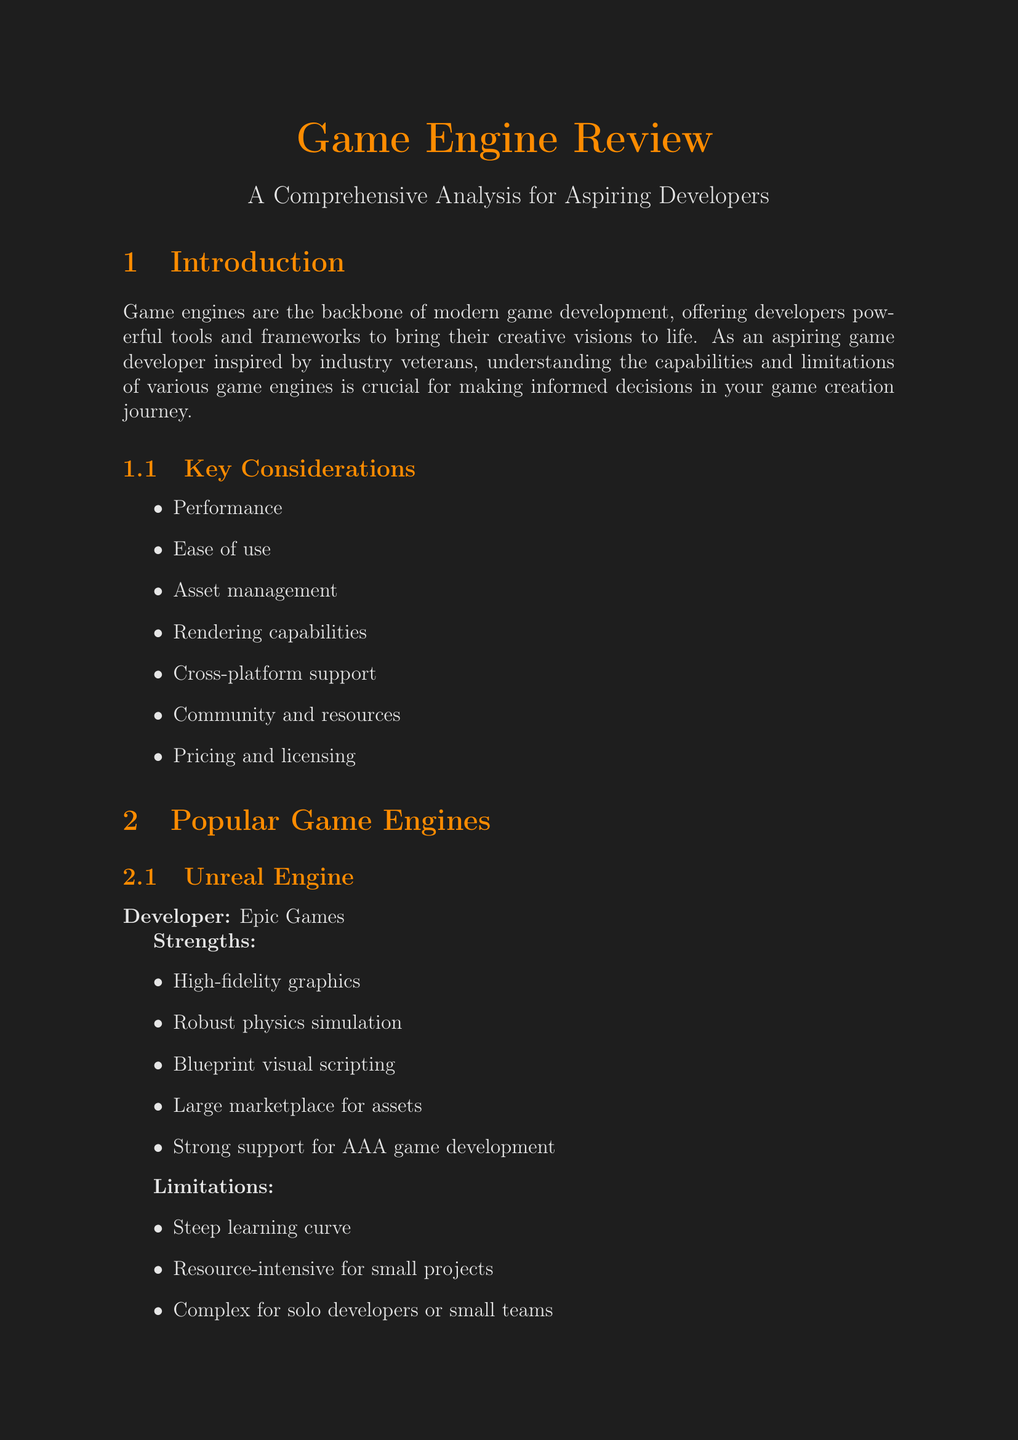what are the key considerations for choosing a game engine? The key considerations listed in the document for choosing a game engine include performance, ease of use, asset management, rendering capabilities, cross-platform support, community and resources, and pricing and licensing.
Answer: performance, ease of use, asset management, rendering capabilities, cross-platform support, community and resources, pricing and licensing what is a strength of Unreal Engine? One of the strengths of Unreal Engine mentioned in the document is its high-fidelity graphics.
Answer: high-fidelity graphics what is a limitation of Godot? The document states that one limitation of Godot is that it has a smaller asset marketplace.
Answer: smaller asset marketplace which game is developed using Unity? Hollow Knight is mentioned as a game developed using Unity.
Answer: Hollow Knight what is the ideal team size for developing with Unity? The document specifies that the ideal team size for Unity development is solo developers to medium-sized teams.
Answer: solo developers to medium-sized teams what type of games is Godot suitable for? Godot is suitable for 2D games, indie projects, prototypes, and educational games.
Answer: 2D games, indie projects, prototypes, educational games what should aspiring developers start with to gain experience? The document advises aspiring developers to start with smaller projects to gain experience.
Answer: smaller projects what is the developer of Unreal Engine? Epic Games is mentioned as the developer of Unreal Engine.
Answer: Epic Games how does community support influence the choice of a game engine? According to the document, community support is crucial as it provides active communities and extensive documentation, which is invaluable for learning and troubleshooting.
Answer: important for learning and troubleshooting 